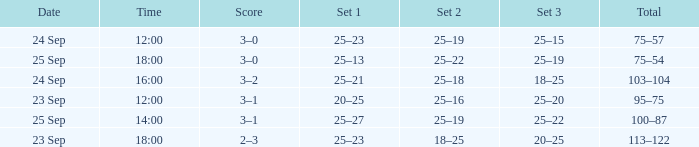What was the score when the time was 14:00? 3–1. 